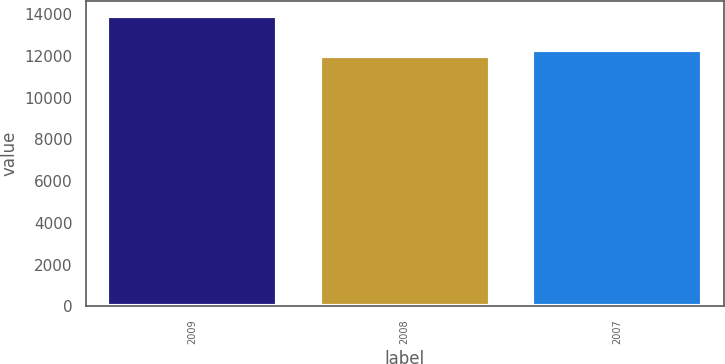Convert chart. <chart><loc_0><loc_0><loc_500><loc_500><bar_chart><fcel>2009<fcel>2008<fcel>2007<nl><fcel>13928<fcel>12002<fcel>12304<nl></chart> 